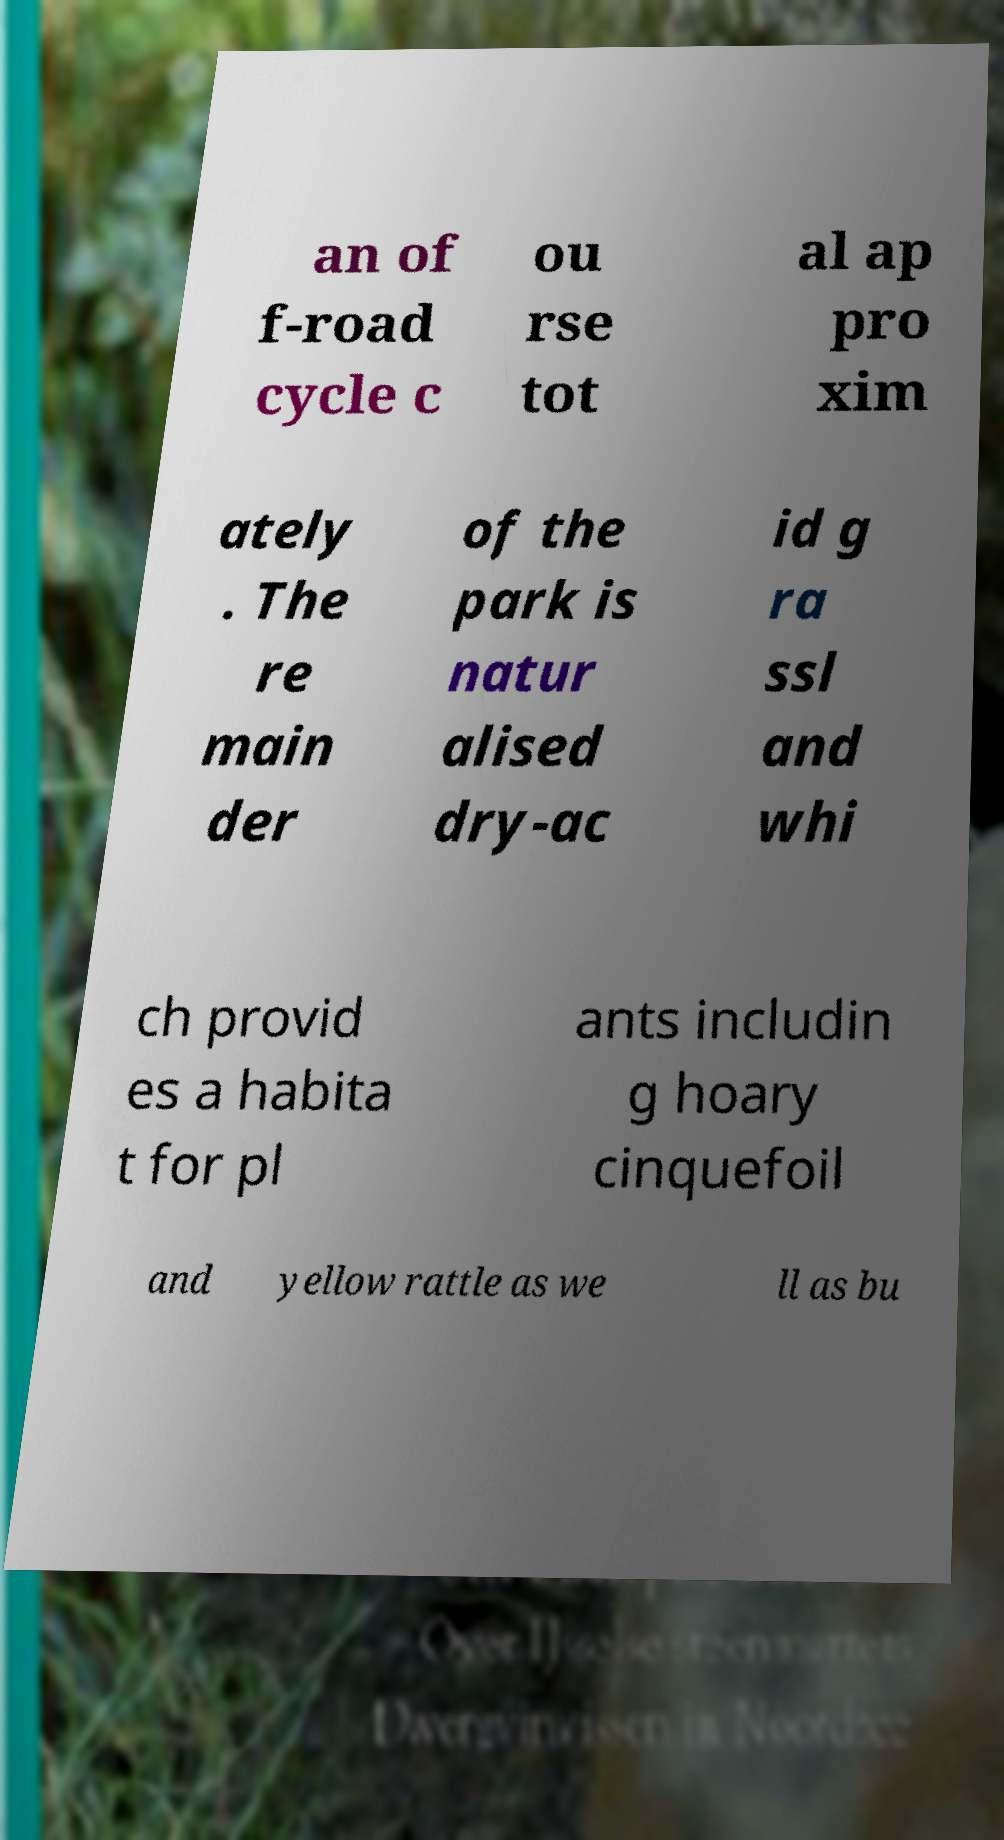I need the written content from this picture converted into text. Can you do that? an of f-road cycle c ou rse tot al ap pro xim ately . The re main der of the park is natur alised dry-ac id g ra ssl and whi ch provid es a habita t for pl ants includin g hoary cinquefoil and yellow rattle as we ll as bu 